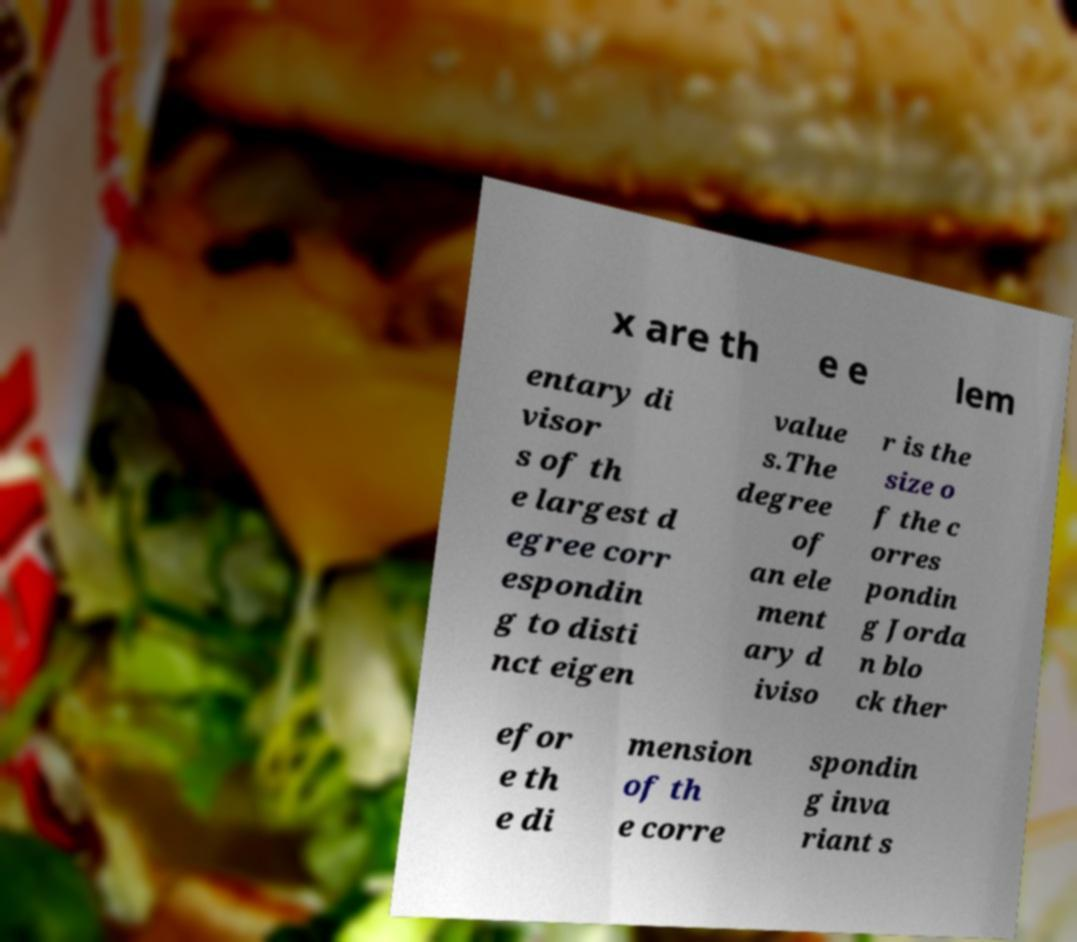Could you assist in decoding the text presented in this image and type it out clearly? x are th e e lem entary di visor s of th e largest d egree corr espondin g to disti nct eigen value s.The degree of an ele ment ary d iviso r is the size o f the c orres pondin g Jorda n blo ck ther efor e th e di mension of th e corre spondin g inva riant s 